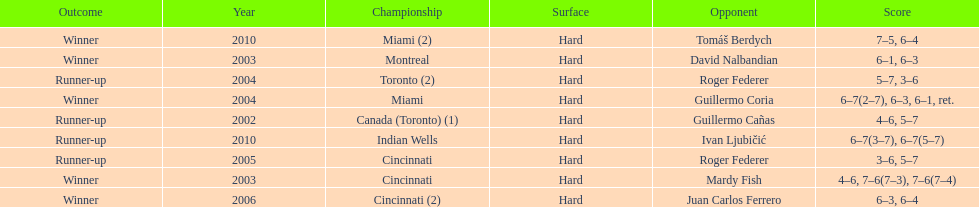How many consecutive years was there a hard surface at the championship? 9. 